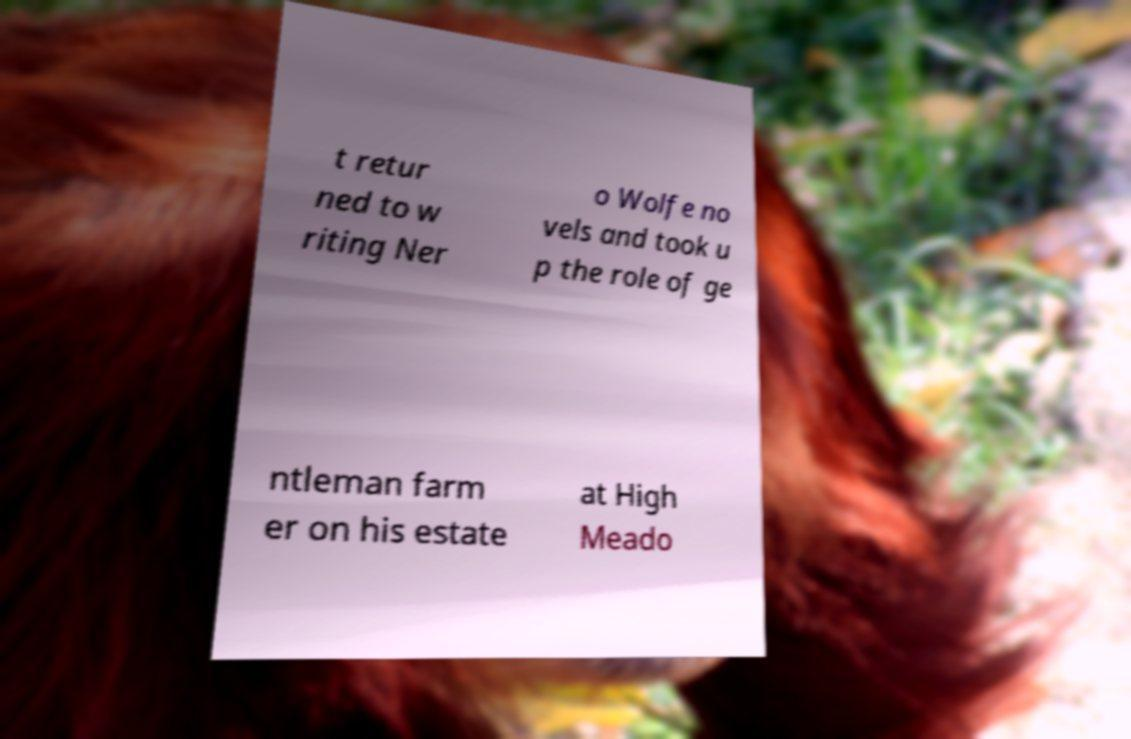Could you extract and type out the text from this image? t retur ned to w riting Ner o Wolfe no vels and took u p the role of ge ntleman farm er on his estate at High Meado 